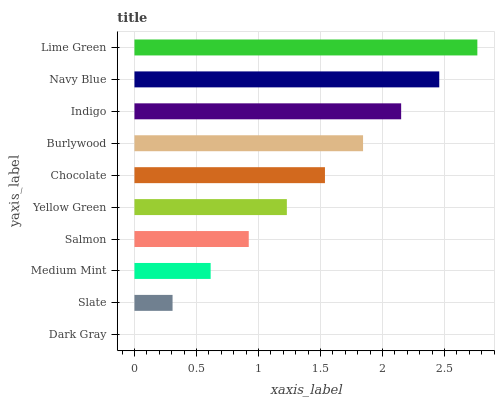Is Dark Gray the minimum?
Answer yes or no. Yes. Is Lime Green the maximum?
Answer yes or no. Yes. Is Slate the minimum?
Answer yes or no. No. Is Slate the maximum?
Answer yes or no. No. Is Slate greater than Dark Gray?
Answer yes or no. Yes. Is Dark Gray less than Slate?
Answer yes or no. Yes. Is Dark Gray greater than Slate?
Answer yes or no. No. Is Slate less than Dark Gray?
Answer yes or no. No. Is Chocolate the high median?
Answer yes or no. Yes. Is Yellow Green the low median?
Answer yes or no. Yes. Is Slate the high median?
Answer yes or no. No. Is Dark Gray the low median?
Answer yes or no. No. 